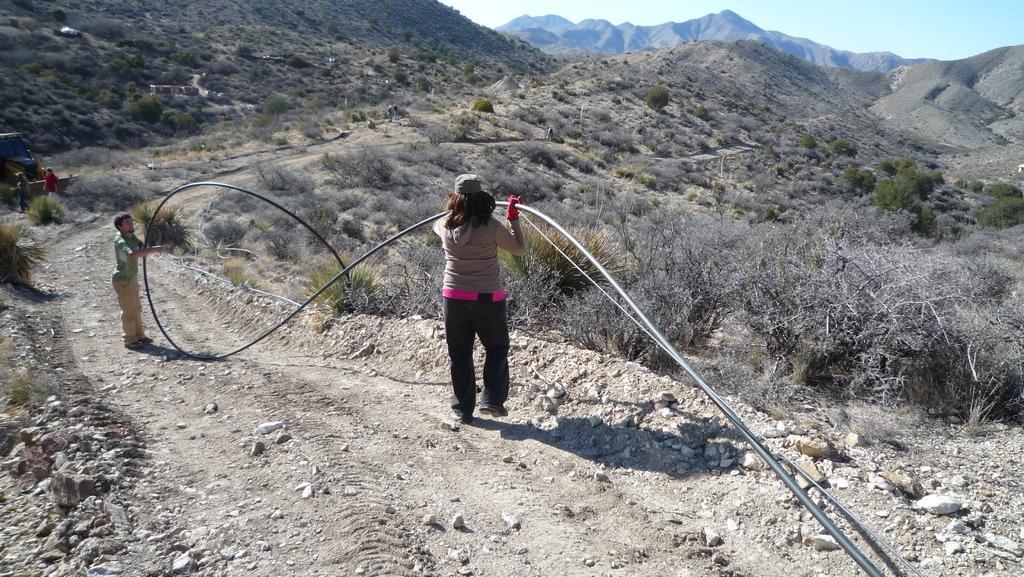Can you describe this image briefly? In the image there are two people standing on a rough surface, they are holding some wires and around them there are many dry plants, on the left side there is a vehicle and few people. In the background there are mountains. 